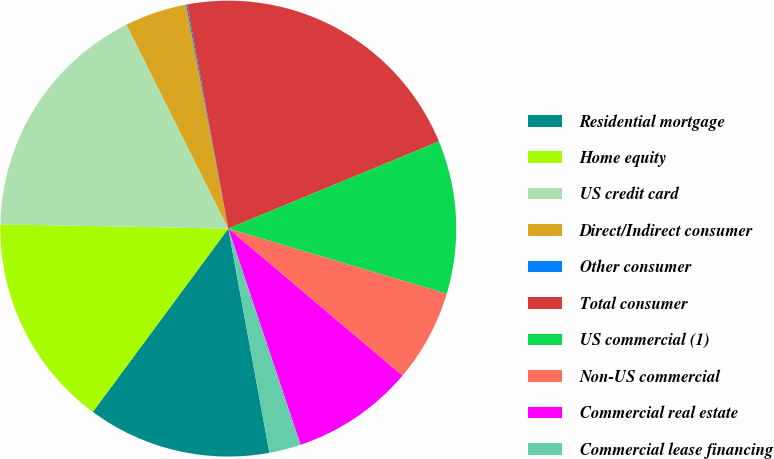Convert chart. <chart><loc_0><loc_0><loc_500><loc_500><pie_chart><fcel>Residential mortgage<fcel>Home equity<fcel>US credit card<fcel>Direct/Indirect consumer<fcel>Other consumer<fcel>Total consumer<fcel>US commercial (1)<fcel>Non-US commercial<fcel>Commercial real estate<fcel>Commercial lease financing<nl><fcel>13.02%<fcel>15.17%<fcel>17.33%<fcel>4.4%<fcel>0.09%<fcel>21.64%<fcel>10.86%<fcel>6.55%<fcel>8.71%<fcel>2.24%<nl></chart> 